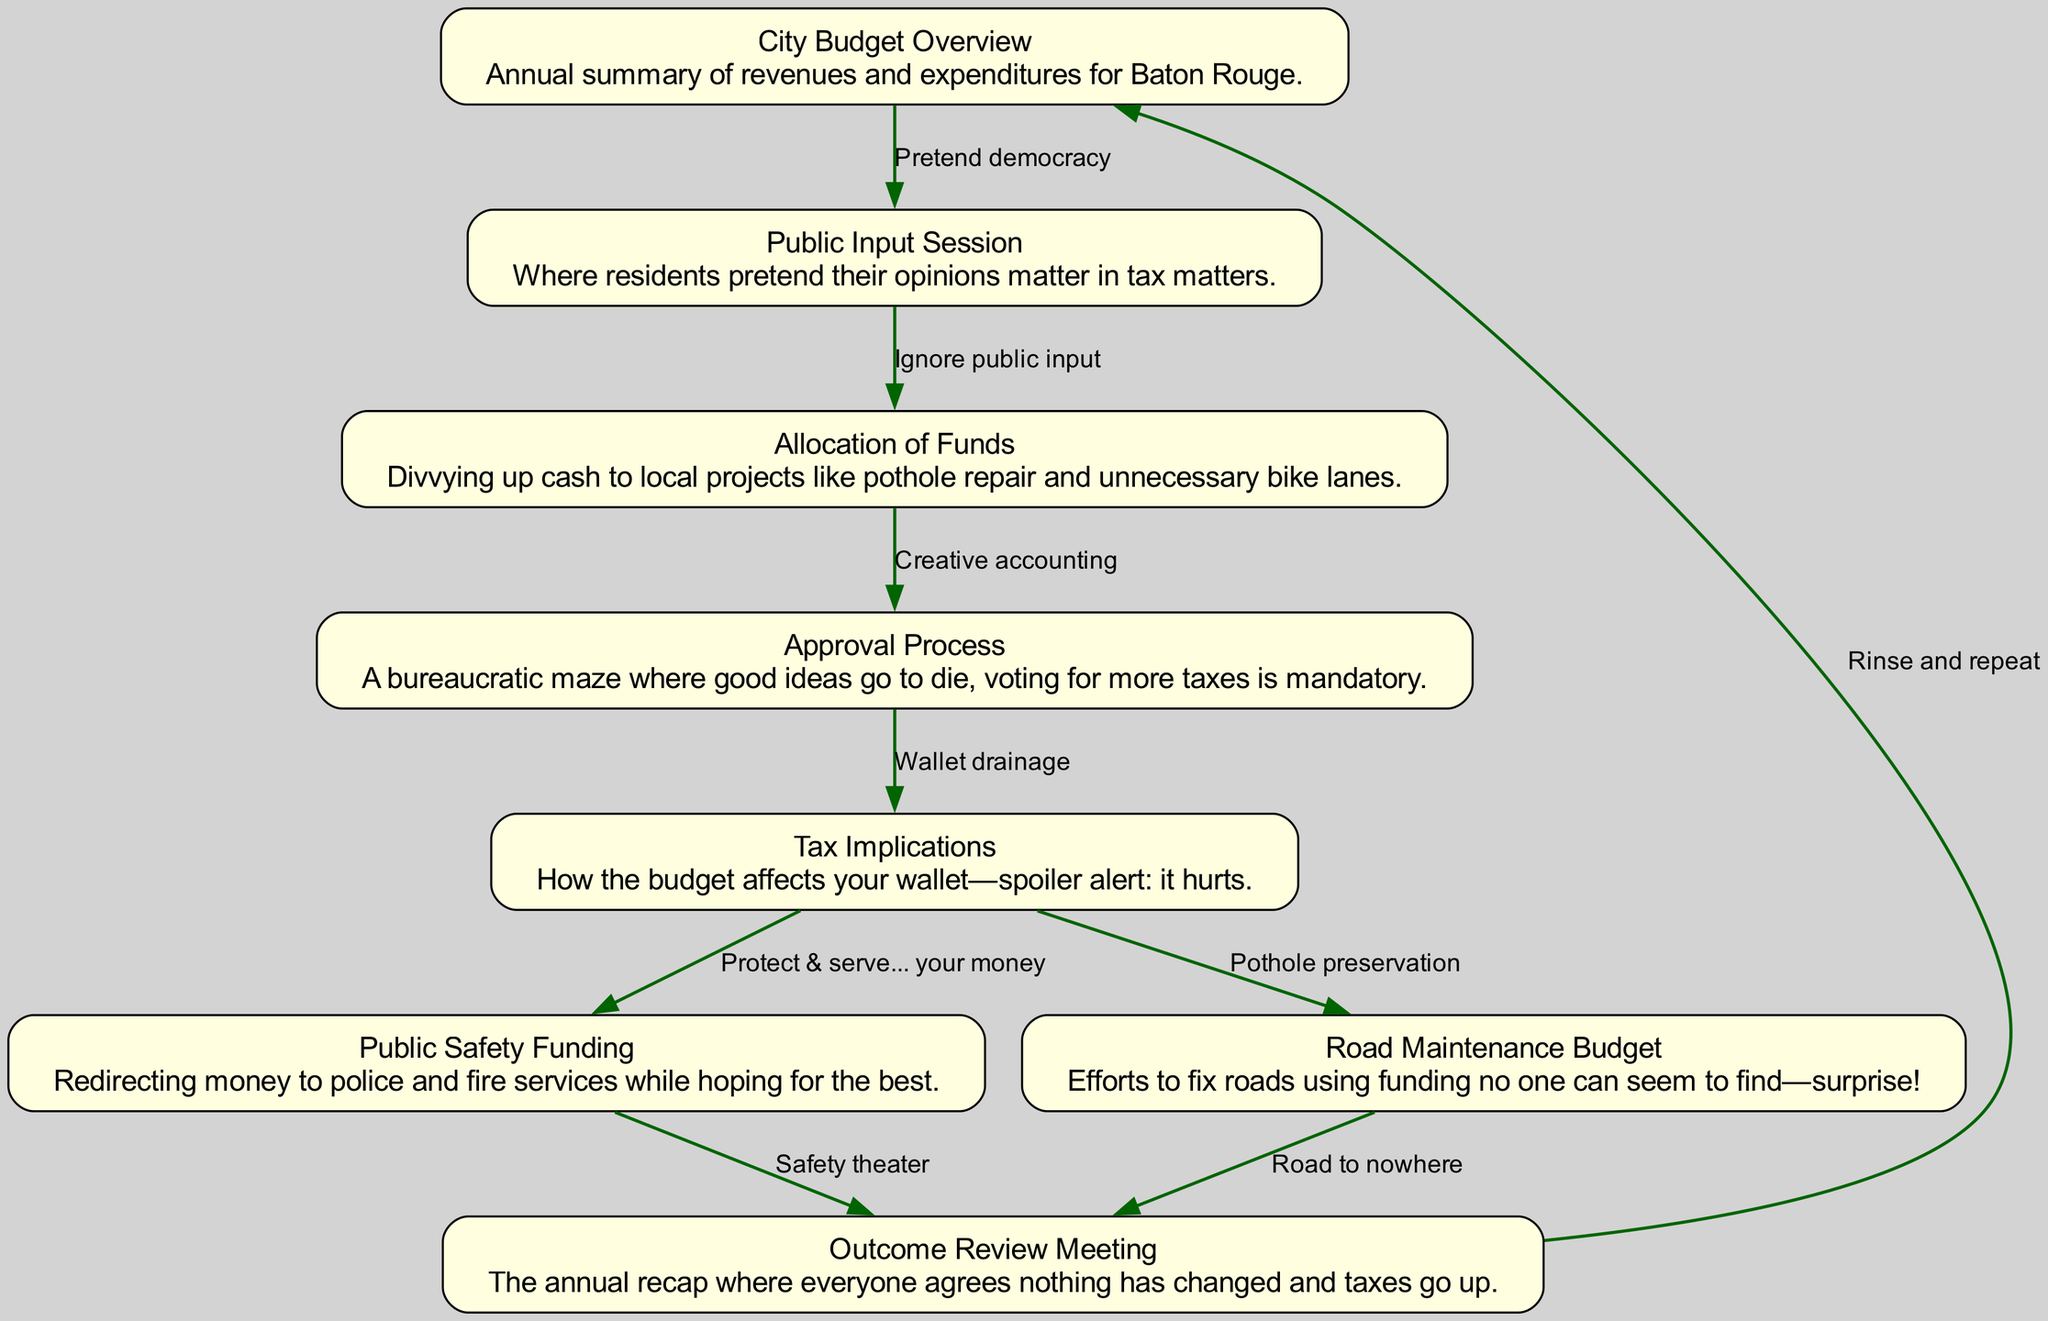What is the starting point of the budget flow? The starting point is the "City Budget Overview," which is the first element in the diagram.
Answer: City Budget Overview How many nodes are in the diagram? There are eight nodes, as listed in the "elements." Each represents a different step or component of the budget process.
Answer: 8 What is the edge relationship between the "Approval Process" and "Tax Implications"? The edge indicates that the "Approval Process" leads directly to "Tax Implications," meaning that the approval affects how taxes will impact residents.
Answer: "Wallet drainage" Which node describes the feedback process at the end of the cycle? The "Outcome Review Meeting" describes the feedback process, summarizing what has occurred throughout the budget year.
Answer: Outcome Review Meeting Which node is connected to both "Public Safety Funding" and "Road Maintenance Budget"? "Tax Implications" is connected to both nodes, indicating that the budget decisions in these areas are directly affected by the overall tax strategies.
Answer: Tax Implications What is implied by the phrase "Rinse and repeat"? It implies that the budget process is cyclical, suggesting that the same issues and patterns recur annually, including potential tax increases.
Answer: Rinse and repeat Which action follows the "Public Input Session"? "Ignore public input" follows the "Public Input Session," indicating that despite the session, residents' opinions are not taken into account in budget decisions.
Answer: Ignore public input What is the common theme throughout the "Road Maintenance Budget"? The theme of finding funding is present, as depicted in the description of the "Road Maintenance Budget" regarding the difficulty of locating adequate funds for repairs.
Answer: Funding no one can seem to find What does the edge leading from "Public Safety Funding" to "Outcome Review Meeting" suggest? It suggests that funding for public safety impacts the review of outcomes, which affects public perception and the financial decisions taken in the meeting.
Answer: Safety theater 